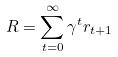Convert formula to latex. <formula><loc_0><loc_0><loc_500><loc_500>R = \sum _ { t = 0 } ^ { \infty } \gamma ^ { t } r _ { t + 1 }</formula> 